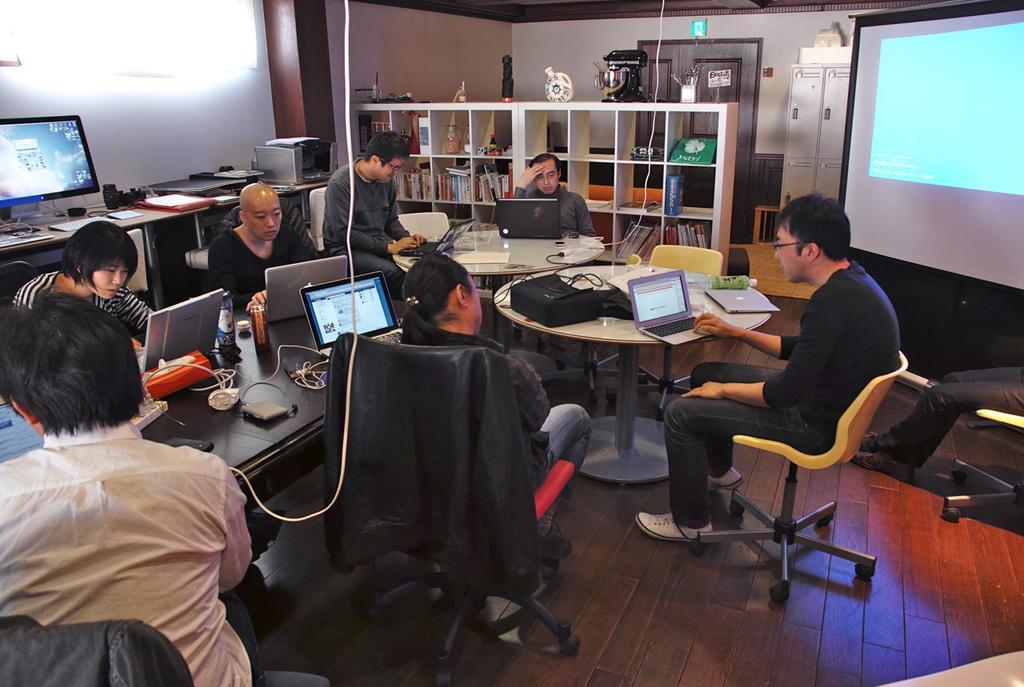How would you summarize this image in a sentence or two? In this image i can see a group of people who are sitting on the chair in front of the table and operating in laptops. On the table we have other objects like bottle. On the right side of the image we have a projector screen and a shelf which has some objects on it. 